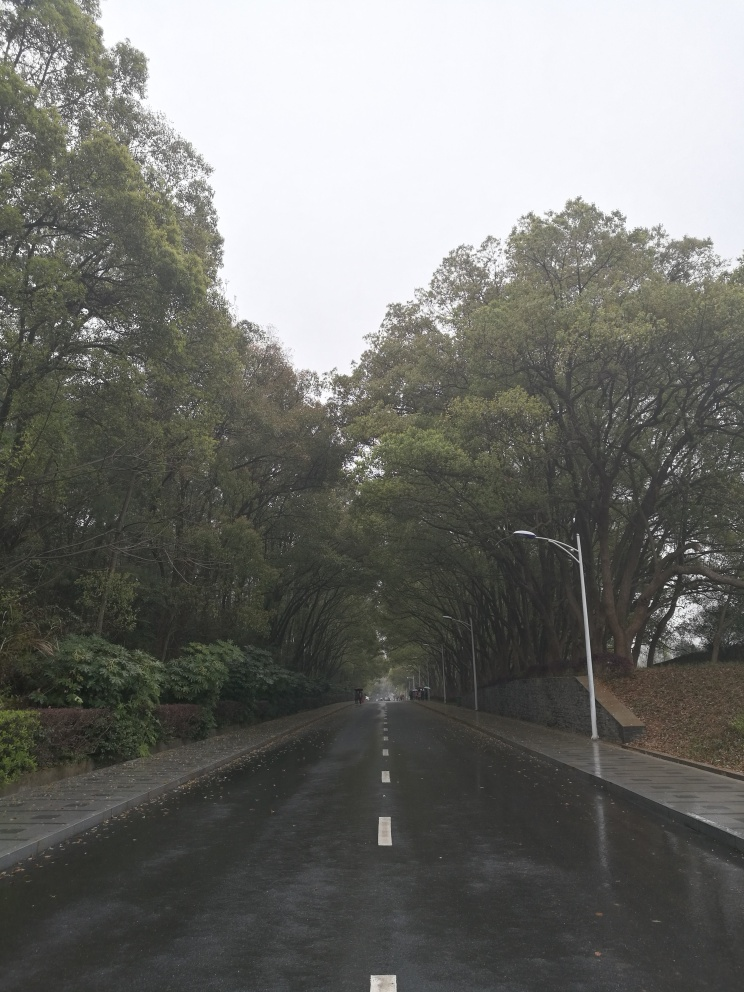Can you comment on the composition and perspective of this photograph? The composition utilizes a symmetrical balance with the road acting as a leading line that draws the eye towards the vanishing point at the center of the photo. The tall trees on either side form a natural archway over the road, enhancing the depth of the scene. This perspective induces a sense of depth and directs focus towards the distance, inviting contemplation about what lies beyond. How does the symmetry affect the overall aesthetics of the photo? Symmetry in this photo contributes to a harmonious and orderly aesthetic, providing a pleasing and balanced visual experience. It imparts a sense of stability and tranquility, which, when combined with the natural elements of the scene, creates an image that is both calming and aesthetically pleasing. 